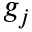<formula> <loc_0><loc_0><loc_500><loc_500>g _ { j }</formula> 